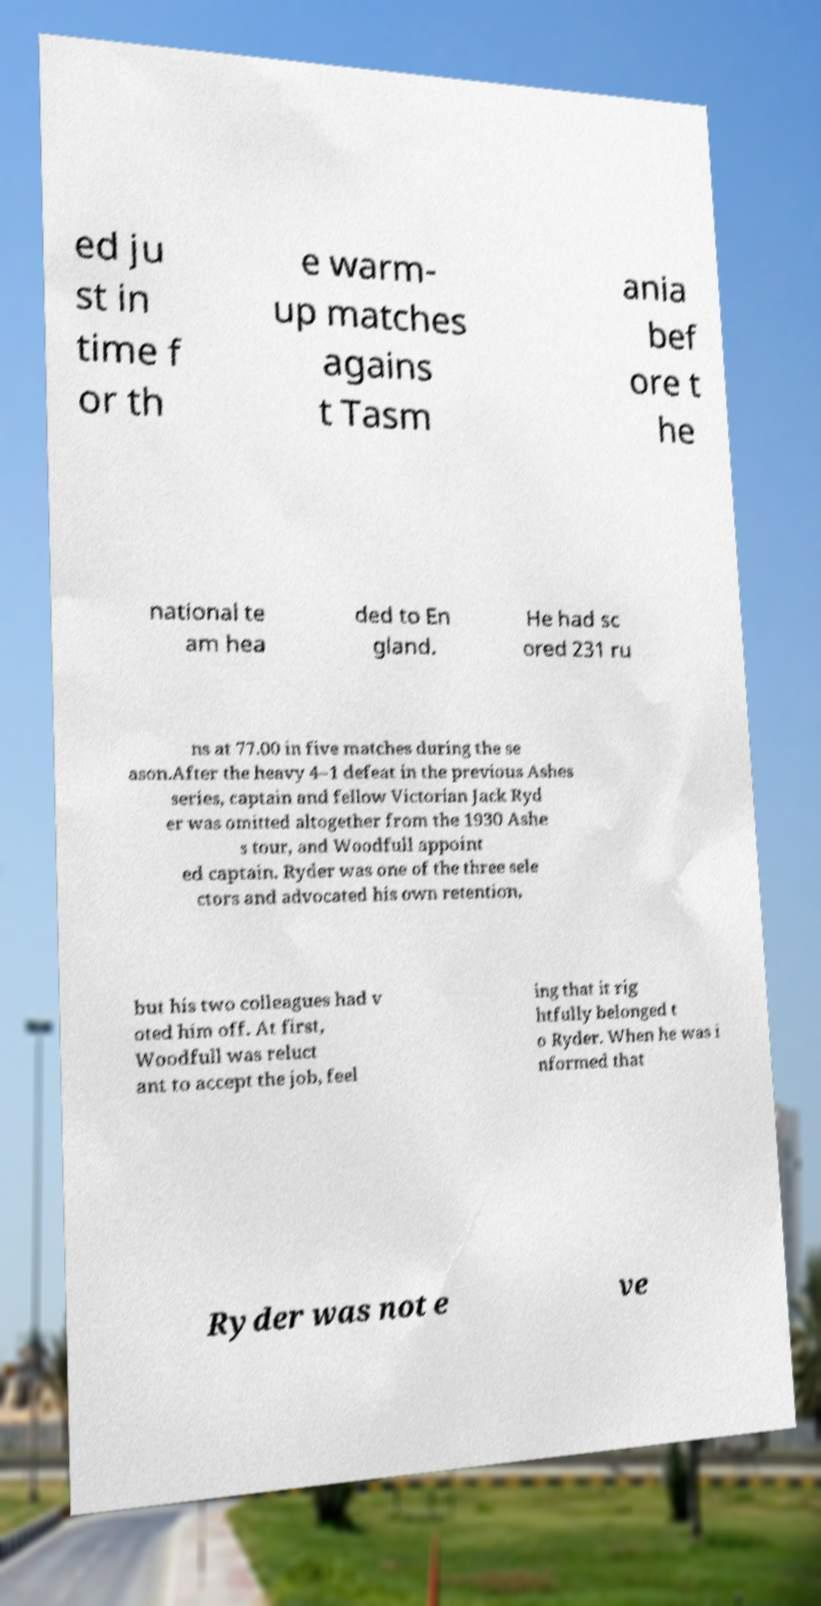What messages or text are displayed in this image? I need them in a readable, typed format. ed ju st in time f or th e warm- up matches agains t Tasm ania bef ore t he national te am hea ded to En gland. He had sc ored 231 ru ns at 77.00 in five matches during the se ason.After the heavy 4–1 defeat in the previous Ashes series, captain and fellow Victorian Jack Ryd er was omitted altogether from the 1930 Ashe s tour, and Woodfull appoint ed captain. Ryder was one of the three sele ctors and advocated his own retention, but his two colleagues had v oted him off. At first, Woodfull was reluct ant to accept the job, feel ing that it rig htfully belonged t o Ryder. When he was i nformed that Ryder was not e ve 